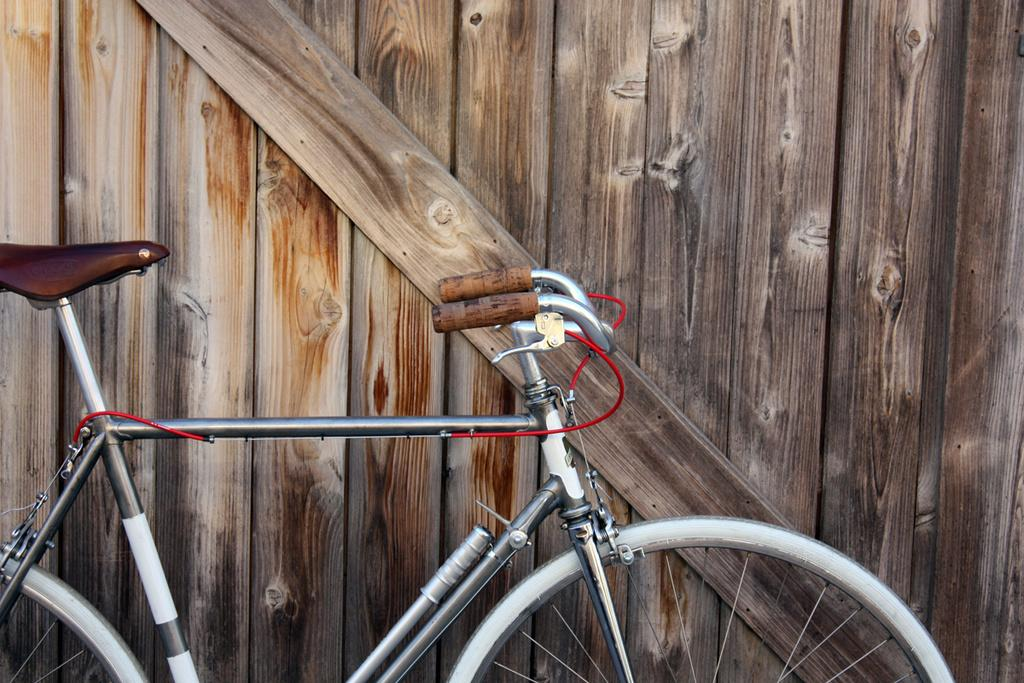What is the main object in the image? There is a bicycle in the image. What can be seen behind the bicycle? There is a wooden wall behind the bicycle. What type of comfort can be seen in the image? There is no reference to comfort in the image, as it features a bicycle and a wooden wall. 